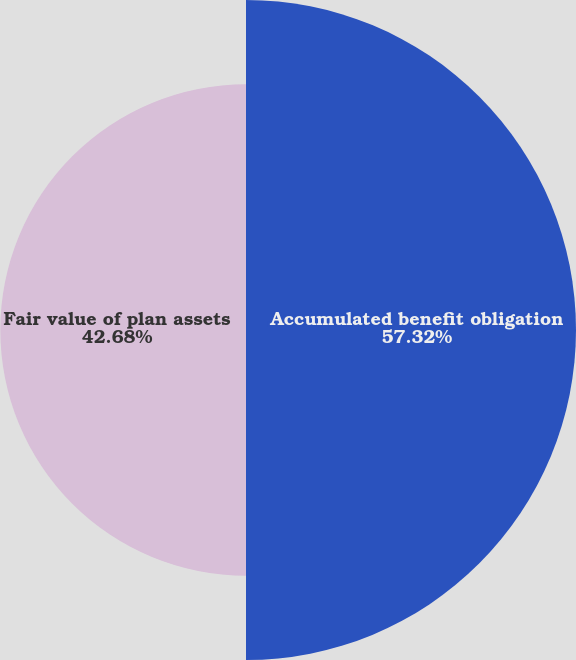Convert chart to OTSL. <chart><loc_0><loc_0><loc_500><loc_500><pie_chart><fcel>Accumulated benefit obligation<fcel>Fair value of plan assets<nl><fcel>57.32%<fcel>42.68%<nl></chart> 